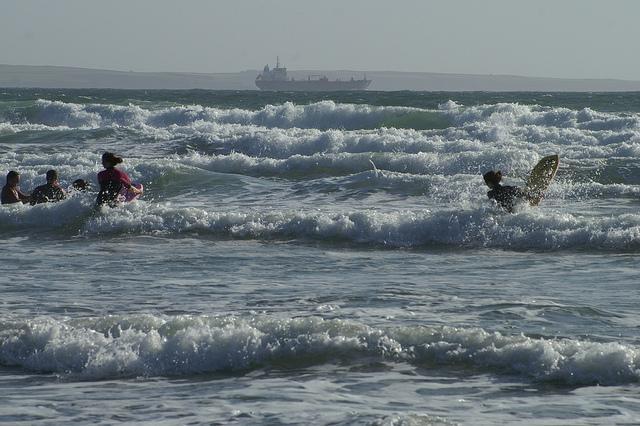How many people in the water?
Give a very brief answer. 5. How many people are in the water?
Give a very brief answer. 4. How many people are standing on their board?
Give a very brief answer. 0. 